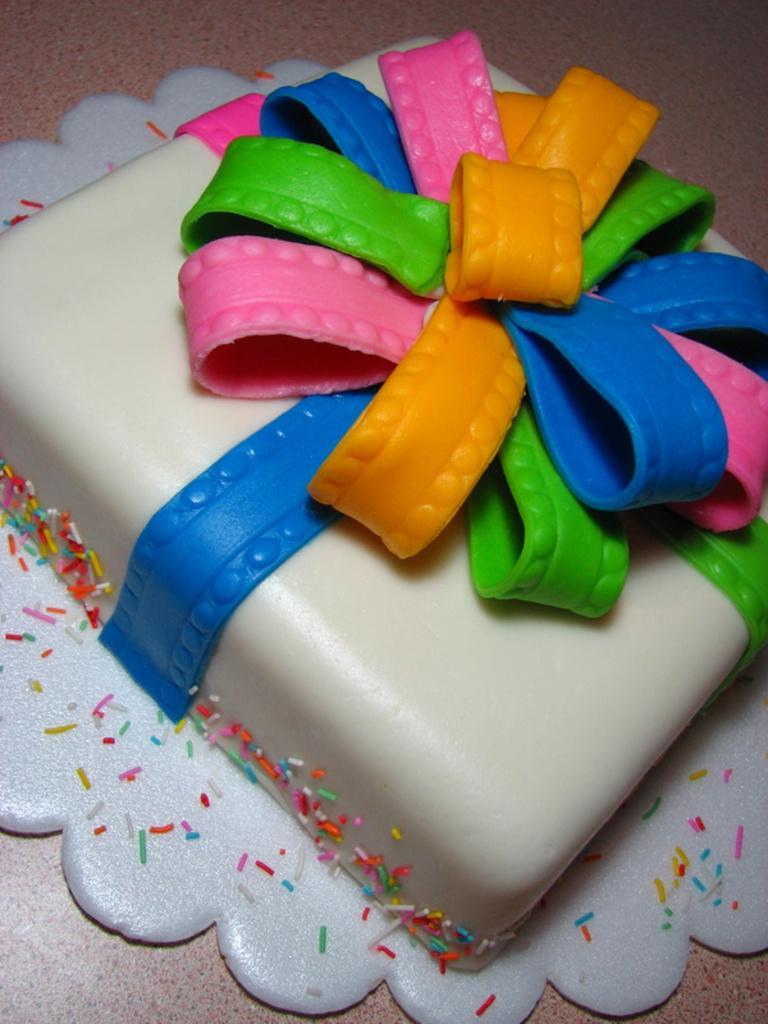Please provide a concise description of this image. In this picture I can see a cake in front, which is of white, blue, yellow, pink and green in color and it is on the brown color surface. 